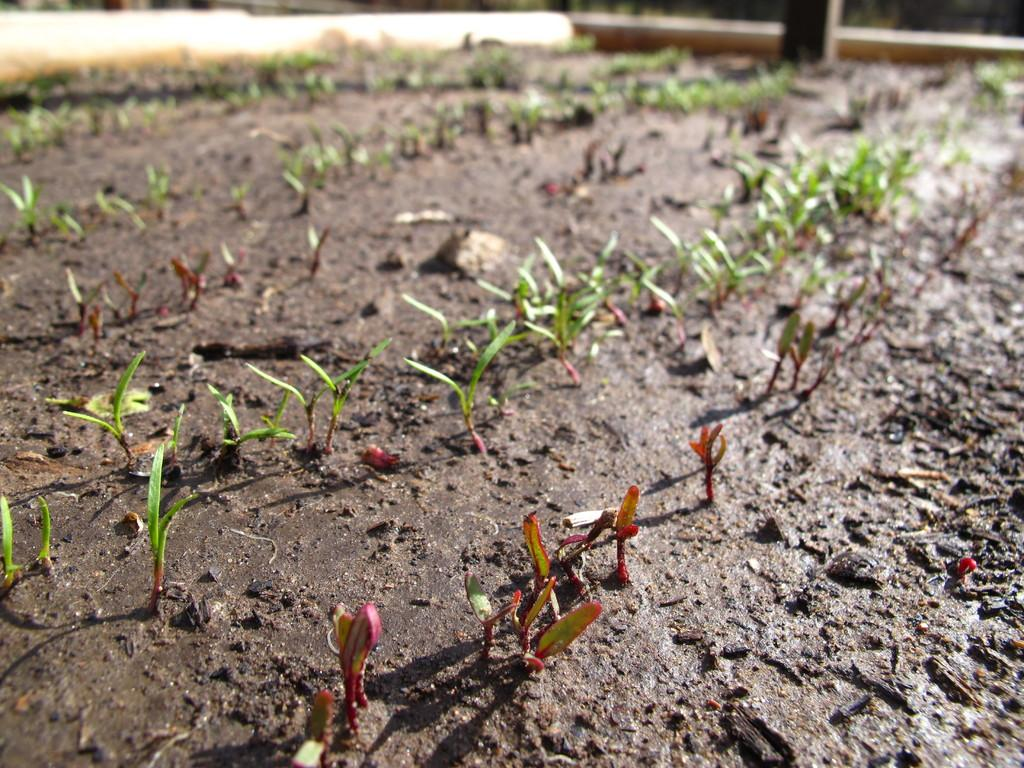What is the primary substance in the image? The image consists of mud. Are there any signs of life in the mud? Yes, there are small sprouts of plants in the mud. What is the color of the plants in the image? The plants are green in color. What is the aftermath of the burst in the image? There is no mention of a burst or any aftermath in the image; it consists of mud with small green plants. 